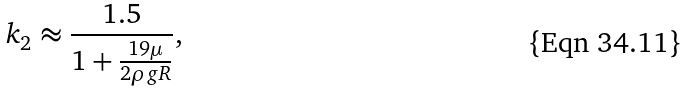Convert formula to latex. <formula><loc_0><loc_0><loc_500><loc_500>k _ { 2 } \approx { \frac { 1 . 5 } { 1 + { \frac { 1 9 \mu } { 2 \rho g R } } } } ,</formula> 